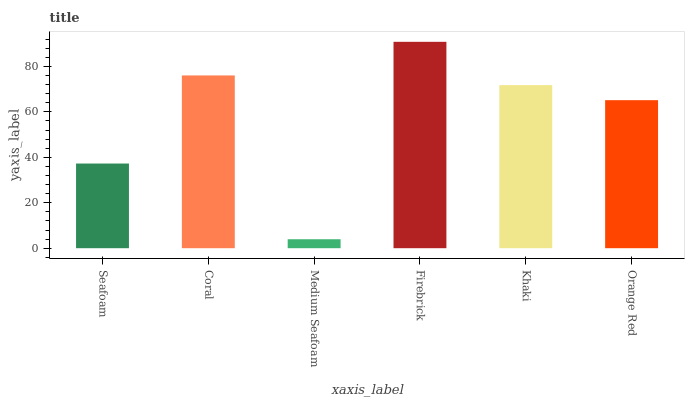Is Medium Seafoam the minimum?
Answer yes or no. Yes. Is Firebrick the maximum?
Answer yes or no. Yes. Is Coral the minimum?
Answer yes or no. No. Is Coral the maximum?
Answer yes or no. No. Is Coral greater than Seafoam?
Answer yes or no. Yes. Is Seafoam less than Coral?
Answer yes or no. Yes. Is Seafoam greater than Coral?
Answer yes or no. No. Is Coral less than Seafoam?
Answer yes or no. No. Is Khaki the high median?
Answer yes or no. Yes. Is Orange Red the low median?
Answer yes or no. Yes. Is Firebrick the high median?
Answer yes or no. No. Is Seafoam the low median?
Answer yes or no. No. 